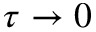Convert formula to latex. <formula><loc_0><loc_0><loc_500><loc_500>\tau \rightarrow 0</formula> 